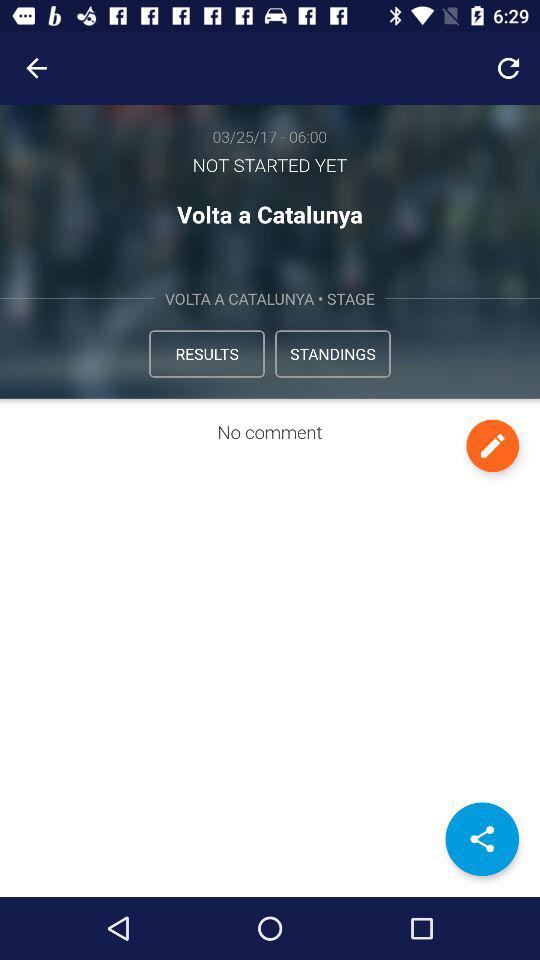What is the time for "Volta a Catalunya"? The time for "Volta a Catalunya" is 06:00. 